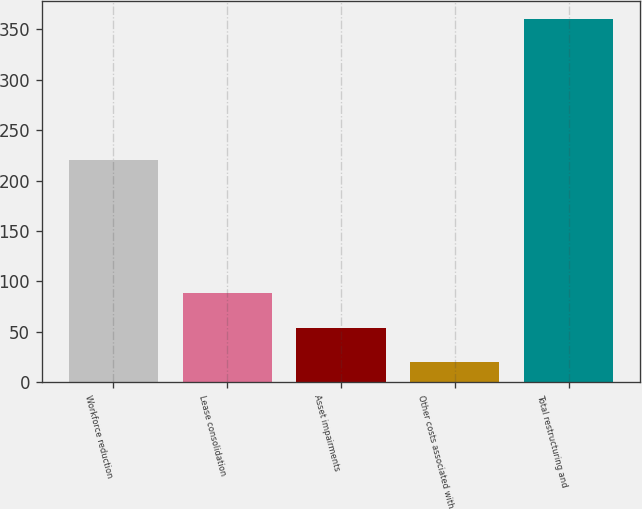<chart> <loc_0><loc_0><loc_500><loc_500><bar_chart><fcel>Workforce reduction<fcel>Lease consolidation<fcel>Asset impairments<fcel>Other costs associated with<fcel>Total restructuring and<nl><fcel>220<fcel>88<fcel>54<fcel>20<fcel>360<nl></chart> 